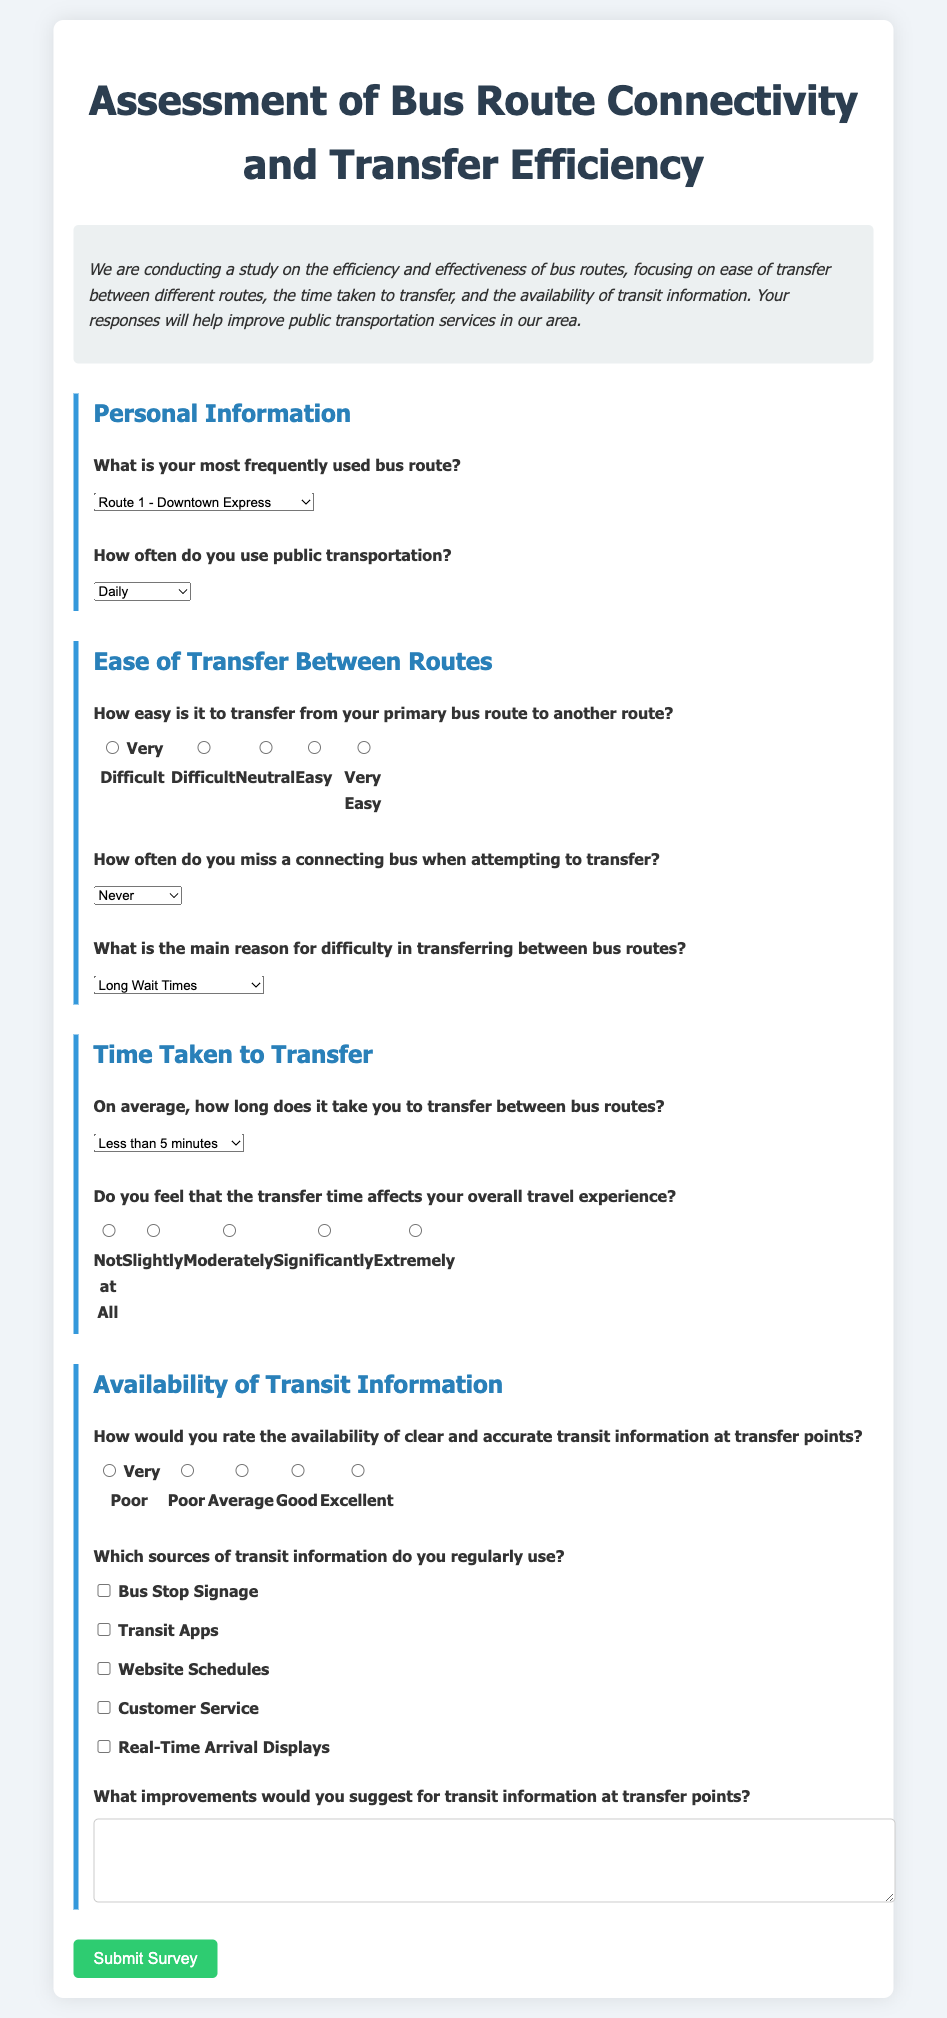What is the title of the survey? The title of the survey is presented at the top of the document in a larger font size and bold style.
Answer: Assessment of Bus Route Connectivity and Transfer Efficiency How many bus route options are provided in the personal information section? The document lists four different bus route options for users to select from in the personal information section.
Answer: 4 What is the highest rating option for the ease of transfer between routes? The highest rating for ease of transfer is indicated in the radio button options for the question about transfer ease.
Answer: Very Easy What is the question regarding the time taken to transfer? The specific question concerning the time taken to transfer is presented with a specific focus on the average duration for transfers between bus routes.
Answer: On average, how long does it take you to transfer between bus routes? How would you categorize the question about improvements for transit information? This question is about gathering qualitative feedback, asking for suggestions on enhancing transit information at transfer points.
Answer: Open-ended question How often can respondents select "Rarely" regarding missing connecting buses? This option is provided in the select dropdown for users to express their experience with missing buses while transferring.
Answer: Rarely What is the format of the response for the availability of transit information? The question regarding the availability of transit information expects a rating, and respondents use radio buttons to provide their answer.
Answer: Rating What kind of sources of transit information are listed in the document? The document provides multiple checkboxes for respondents to indicate the sources of transit information they use regularly.
Answer: Bus Stop Signage, Transit Apps, Website Schedules, Customer Service, Real-Time Arrival Displays What is the purpose of the survey as stated in the introduction? The purpose is outlined in the introduction, and it guides the intent behind conducting the study.
Answer: Improve public transportation services in our area 